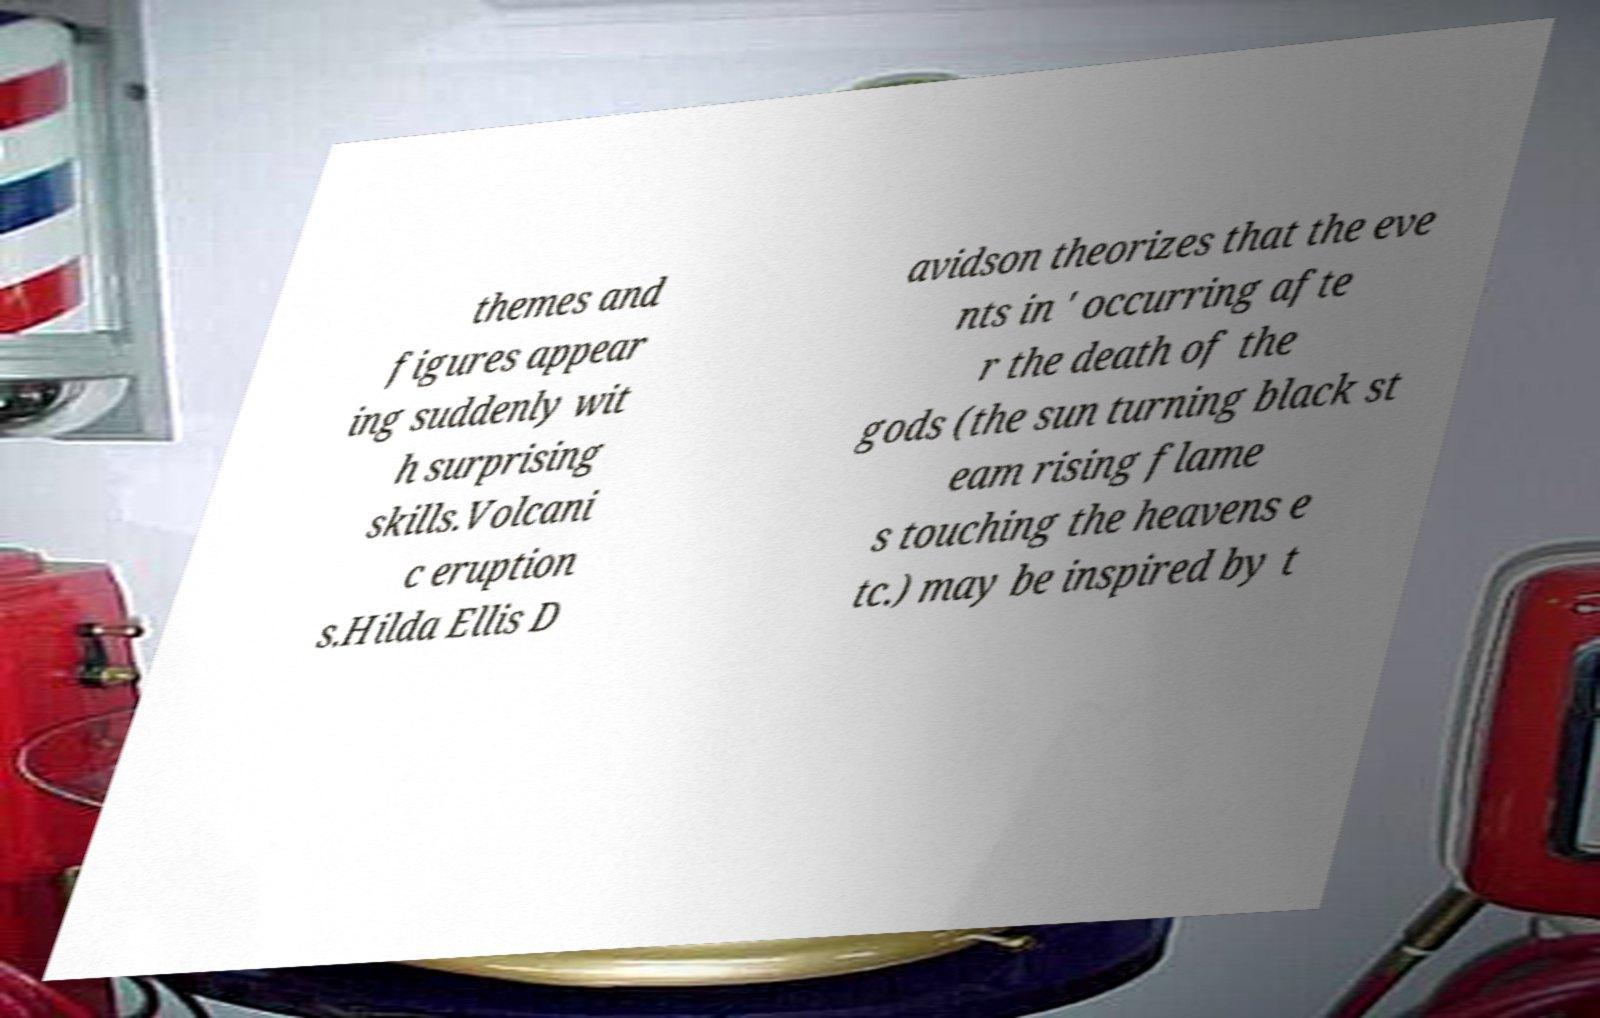Can you accurately transcribe the text from the provided image for me? themes and figures appear ing suddenly wit h surprising skills.Volcani c eruption s.Hilda Ellis D avidson theorizes that the eve nts in ' occurring afte r the death of the gods (the sun turning black st eam rising flame s touching the heavens e tc.) may be inspired by t 